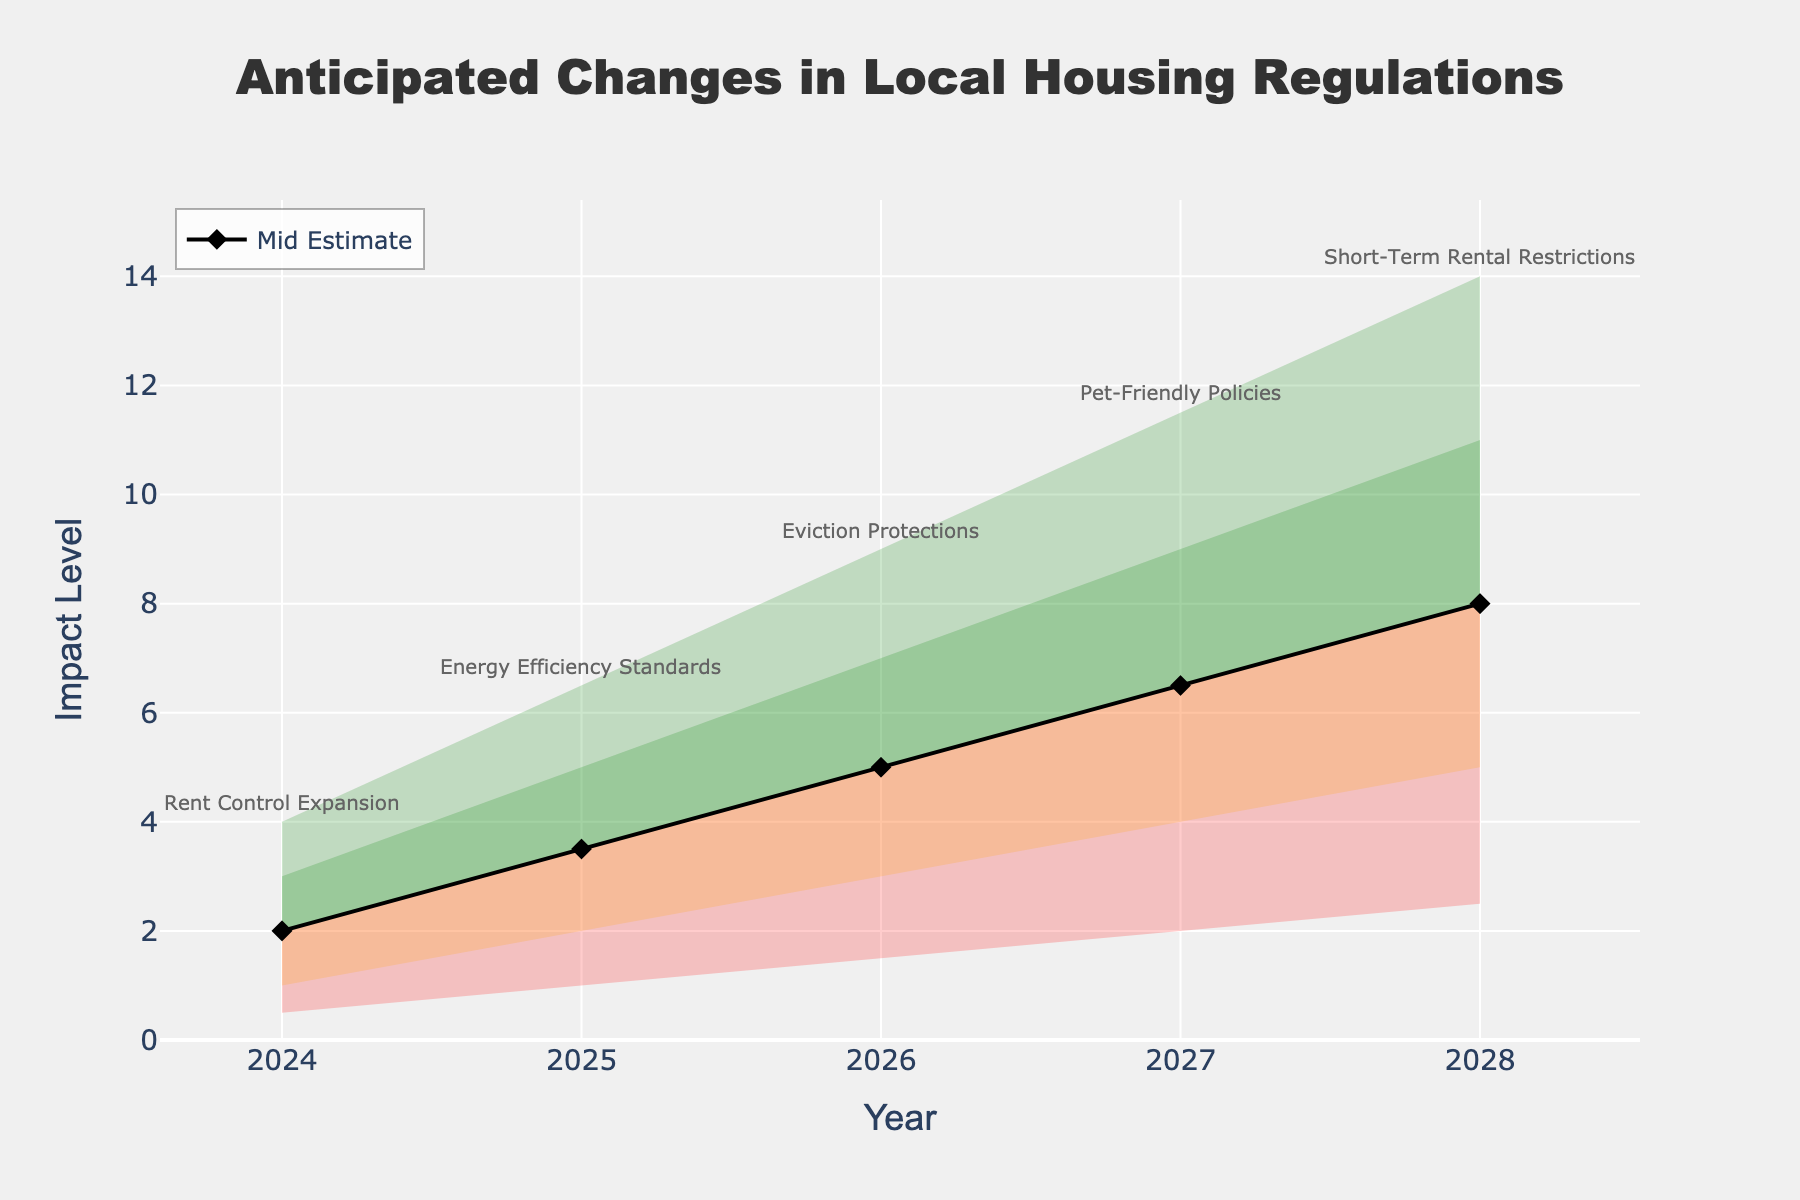What's the title of the chart? The title of the chart is located at the top and is usually the most prominent text in the visualization.
Answer: Anticipated Changes in Local Housing Regulations What is the expected impact level in 2025 according to the mid estimate? To answer this, locate the mid estimate on the y-axis for the year 2025. The mid estimate line is marked by a black line and diamond symbols.
Answer: 3.5 Which regulation is expected to have the highest impact in 2027, according to the high estimate? To answer this, look at the highest point for the year 2027 on the y-axis where the high estimate is marked and find the annotation text.
Answer: Pet-Friendly Policies How does the anticipated impact level of eviction protections in 2026 compare to the impact of energy efficiency standards in 2025, using mid-level estimates? First, find the mid-level estimate for both years (5.0 for 2026 and 3.5 for 2025) and compare them.
Answer: 2026 is higher What's the average impact level of rent control expansion over its range (low to high) in 2024? To find the average, take the sum of the low, low-mid, mid, mid-high, and high estimates for 2024 and divide by 5 ((0.5 + 1.0 + 2.0 + 3.0 + 4.0) / 5).
Answer: 2.1 Which year has the least anticipated impact on lease terms for the high estimate, and what is that value? Look at the values of the high estimates for all years and find the smallest one.
Answer: 2024, 4.0 In 2028, compare the low-mid estimate with the high estimate. What is the difference between them? Subtract the low-mid estimate from the high estimate for the year 2028 (14.0 - 5.0).
Answer: 9.0 What trend can you identify in the anticipated impact levels over the years for the mid estimate? Look at the mid estimate values from 2024 to 2028 and observe if they are increasing, decreasing, or remaining constant.
Answer: Increasing trend 